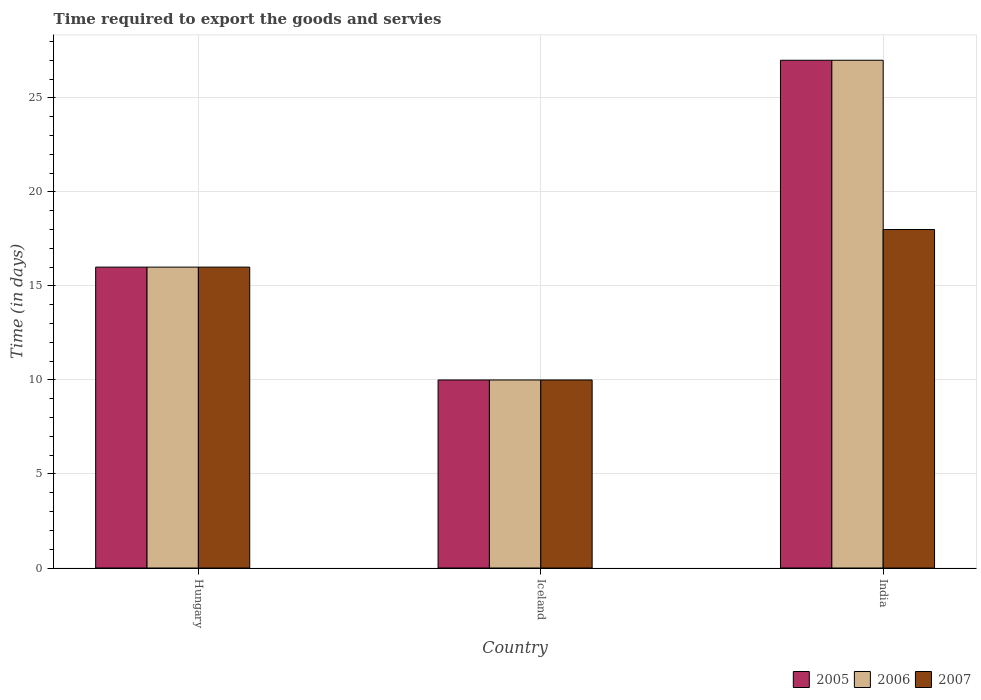How many groups of bars are there?
Your answer should be compact. 3. Are the number of bars per tick equal to the number of legend labels?
Provide a succinct answer. Yes. How many bars are there on the 2nd tick from the right?
Your answer should be very brief. 3. Across all countries, what is the minimum number of days required to export the goods and services in 2007?
Keep it short and to the point. 10. What is the difference between the number of days required to export the goods and services in 2007 in Hungary and the number of days required to export the goods and services in 2006 in India?
Your answer should be compact. -11. What is the average number of days required to export the goods and services in 2006 per country?
Your response must be concise. 17.67. What is the difference between the number of days required to export the goods and services of/in 2007 and number of days required to export the goods and services of/in 2005 in Iceland?
Offer a terse response. 0. In how many countries, is the number of days required to export the goods and services in 2006 greater than 27 days?
Your response must be concise. 0. What is the ratio of the number of days required to export the goods and services in 2006 in Hungary to that in India?
Your answer should be compact. 0.59. Is the number of days required to export the goods and services in 2006 in Hungary less than that in Iceland?
Provide a short and direct response. No. How many bars are there?
Your answer should be very brief. 9. Are all the bars in the graph horizontal?
Provide a short and direct response. No. How many countries are there in the graph?
Give a very brief answer. 3. Are the values on the major ticks of Y-axis written in scientific E-notation?
Provide a succinct answer. No. Does the graph contain grids?
Your answer should be compact. Yes. What is the title of the graph?
Ensure brevity in your answer.  Time required to export the goods and servies. Does "1988" appear as one of the legend labels in the graph?
Your response must be concise. No. What is the label or title of the Y-axis?
Your answer should be very brief. Time (in days). What is the Time (in days) of 2007 in Iceland?
Keep it short and to the point. 10. What is the Time (in days) in 2006 in India?
Ensure brevity in your answer.  27. Across all countries, what is the maximum Time (in days) in 2005?
Ensure brevity in your answer.  27. Across all countries, what is the maximum Time (in days) in 2006?
Keep it short and to the point. 27. Across all countries, what is the maximum Time (in days) in 2007?
Keep it short and to the point. 18. Across all countries, what is the minimum Time (in days) in 2005?
Ensure brevity in your answer.  10. Across all countries, what is the minimum Time (in days) of 2007?
Your response must be concise. 10. What is the total Time (in days) of 2005 in the graph?
Make the answer very short. 53. What is the total Time (in days) of 2006 in the graph?
Make the answer very short. 53. What is the difference between the Time (in days) in 2006 in Hungary and that in Iceland?
Keep it short and to the point. 6. What is the difference between the Time (in days) in 2006 in Hungary and that in India?
Give a very brief answer. -11. What is the difference between the Time (in days) of 2005 in Hungary and the Time (in days) of 2007 in Iceland?
Provide a short and direct response. 6. What is the difference between the Time (in days) in 2006 in Hungary and the Time (in days) in 2007 in Iceland?
Your answer should be compact. 6. What is the difference between the Time (in days) of 2006 in Hungary and the Time (in days) of 2007 in India?
Keep it short and to the point. -2. What is the average Time (in days) in 2005 per country?
Your answer should be compact. 17.67. What is the average Time (in days) in 2006 per country?
Provide a short and direct response. 17.67. What is the average Time (in days) in 2007 per country?
Ensure brevity in your answer.  14.67. What is the difference between the Time (in days) of 2005 and Time (in days) of 2006 in Hungary?
Your answer should be compact. 0. What is the difference between the Time (in days) of 2006 and Time (in days) of 2007 in Hungary?
Your answer should be compact. 0. What is the difference between the Time (in days) in 2005 and Time (in days) in 2006 in Iceland?
Offer a very short reply. 0. What is the difference between the Time (in days) of 2006 and Time (in days) of 2007 in Iceland?
Make the answer very short. 0. What is the difference between the Time (in days) in 2005 and Time (in days) in 2007 in India?
Make the answer very short. 9. What is the ratio of the Time (in days) of 2005 in Hungary to that in Iceland?
Your answer should be very brief. 1.6. What is the ratio of the Time (in days) in 2006 in Hungary to that in Iceland?
Offer a terse response. 1.6. What is the ratio of the Time (in days) in 2005 in Hungary to that in India?
Ensure brevity in your answer.  0.59. What is the ratio of the Time (in days) in 2006 in Hungary to that in India?
Give a very brief answer. 0.59. What is the ratio of the Time (in days) in 2007 in Hungary to that in India?
Provide a short and direct response. 0.89. What is the ratio of the Time (in days) of 2005 in Iceland to that in India?
Your answer should be compact. 0.37. What is the ratio of the Time (in days) of 2006 in Iceland to that in India?
Your response must be concise. 0.37. What is the ratio of the Time (in days) of 2007 in Iceland to that in India?
Provide a short and direct response. 0.56. What is the difference between the highest and the second highest Time (in days) in 2006?
Your answer should be compact. 11. What is the difference between the highest and the second highest Time (in days) of 2007?
Make the answer very short. 2. What is the difference between the highest and the lowest Time (in days) of 2005?
Offer a terse response. 17. What is the difference between the highest and the lowest Time (in days) in 2006?
Your answer should be very brief. 17. What is the difference between the highest and the lowest Time (in days) in 2007?
Offer a very short reply. 8. 